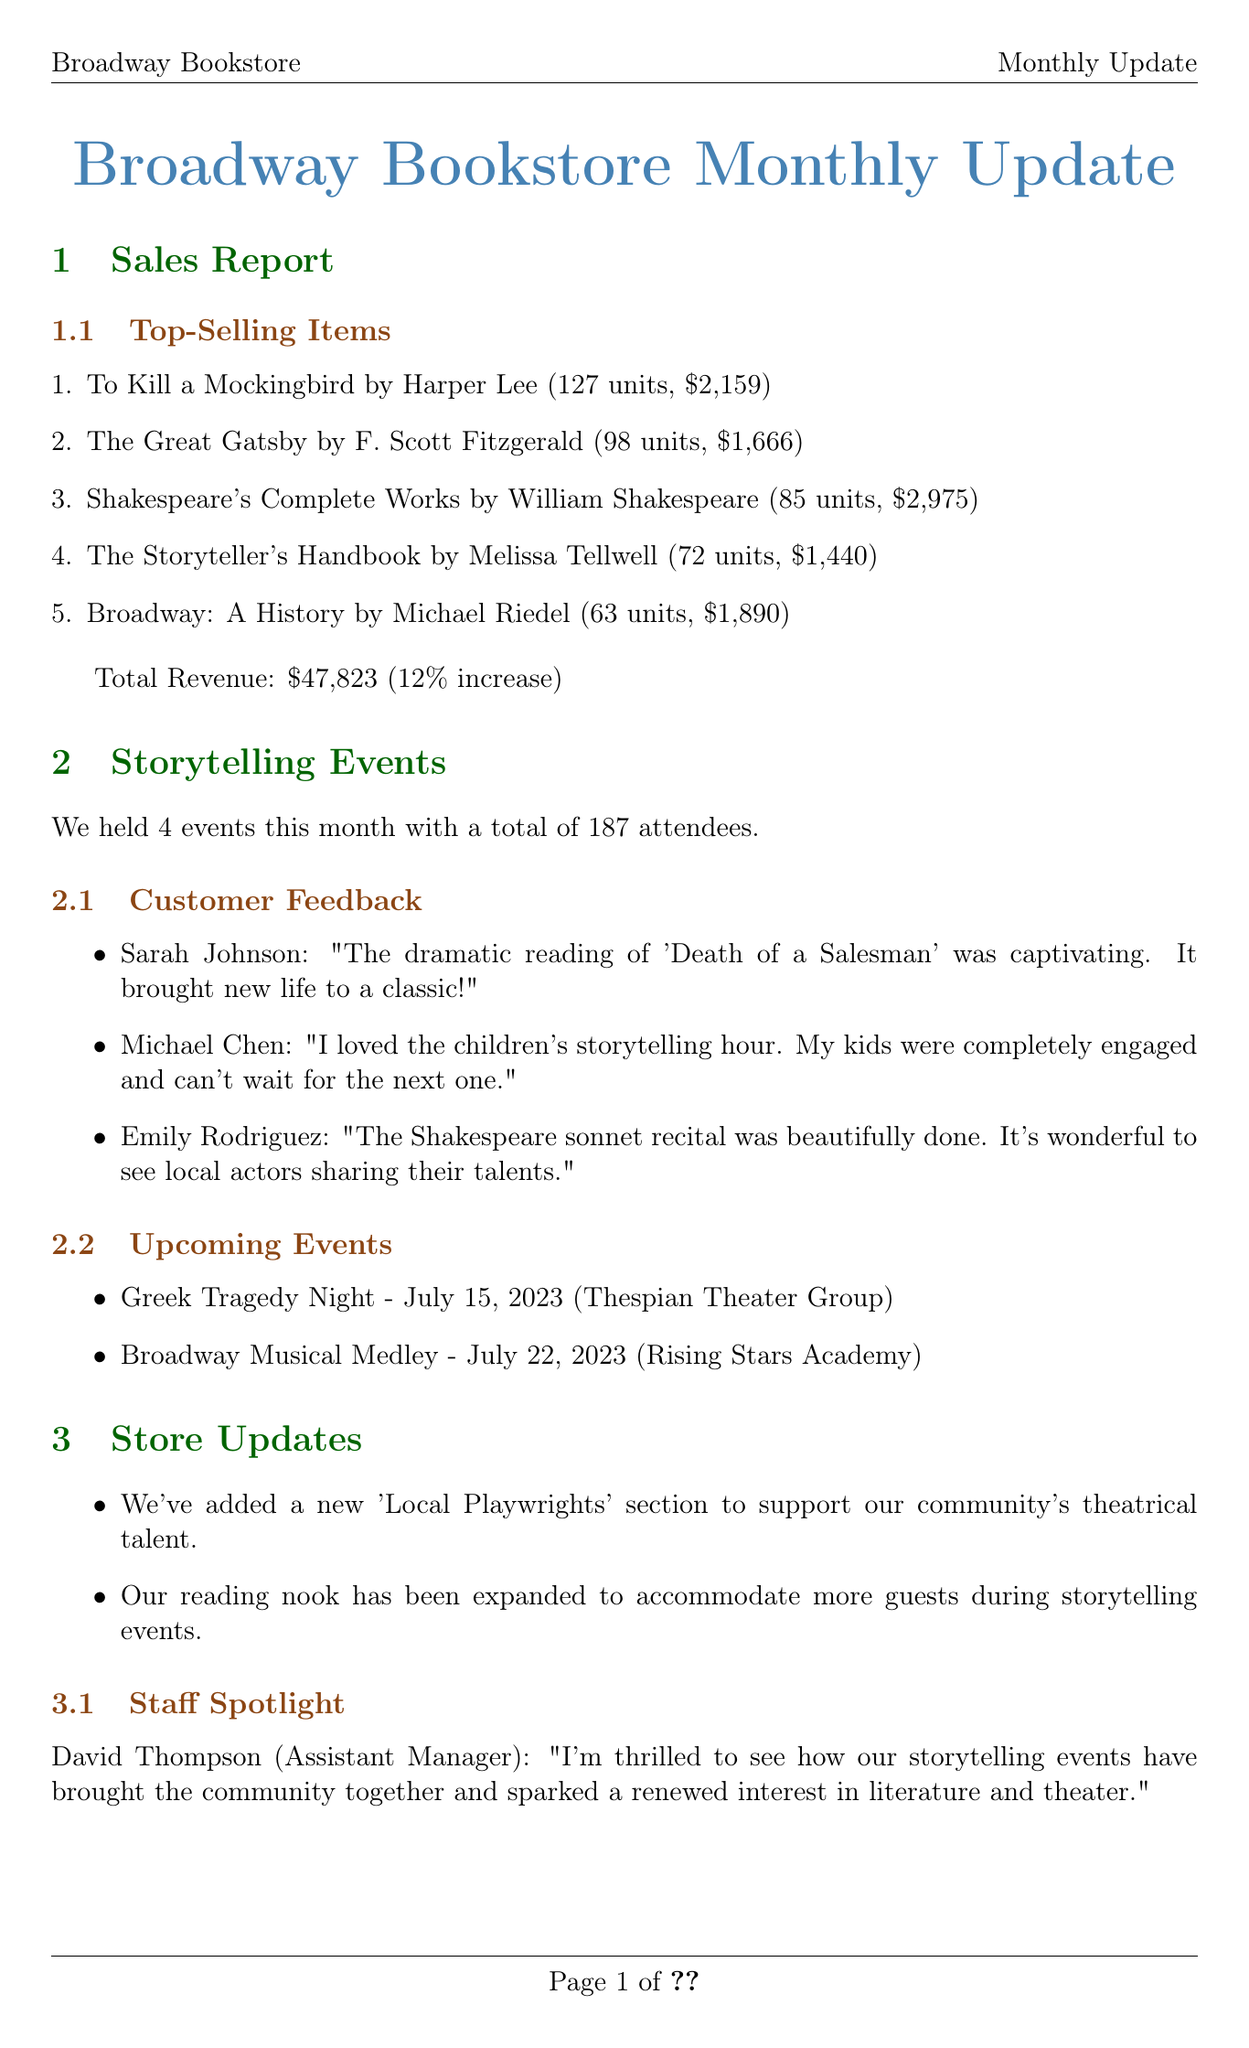What are the top-selling items? The top-selling items are listed in the sales report section, including titles and their corresponding sales figures.
Answer: To Kill a Mockingbird, The Great Gatsby, Shakespeare's Complete Works, The Storyteller's Handbook, Broadway: A History How many units of "The Great Gatsby" were sold? The document specifies the number of units sold for each top-selling item, including "The Great Gatsby."
Answer: 98 What was the total revenue for the month? The document provides a specific revenue figure in the sales report, indicating the total revenue generated.
Answer: $47,823 How many storytelling events were held this month? The number of storytelling events held is indicated in the storytelling events section of the document.
Answer: 4 What is one upcoming event mentioned? The upcoming events are listed in the document; one of them can be identified by looking at that section.
Answer: Greek Tragedy Night Who is the staff spotlighted in the document? The document highlights a staff member in the store updates section, providing their name and role.
Answer: David Thompson What feedback did Sarah Johnson provide? Customer feedback is documented, and Sarah Johnson's comment can be found under that section.
Answer: "The dramatic reading of 'Death of a Salesman' was captivating. It brought new life to a classic!" What percentage increase in total revenue is mentioned? The percent increase is specified in the sales report section, providing insight into the month’s performance.
Answer: 12% 